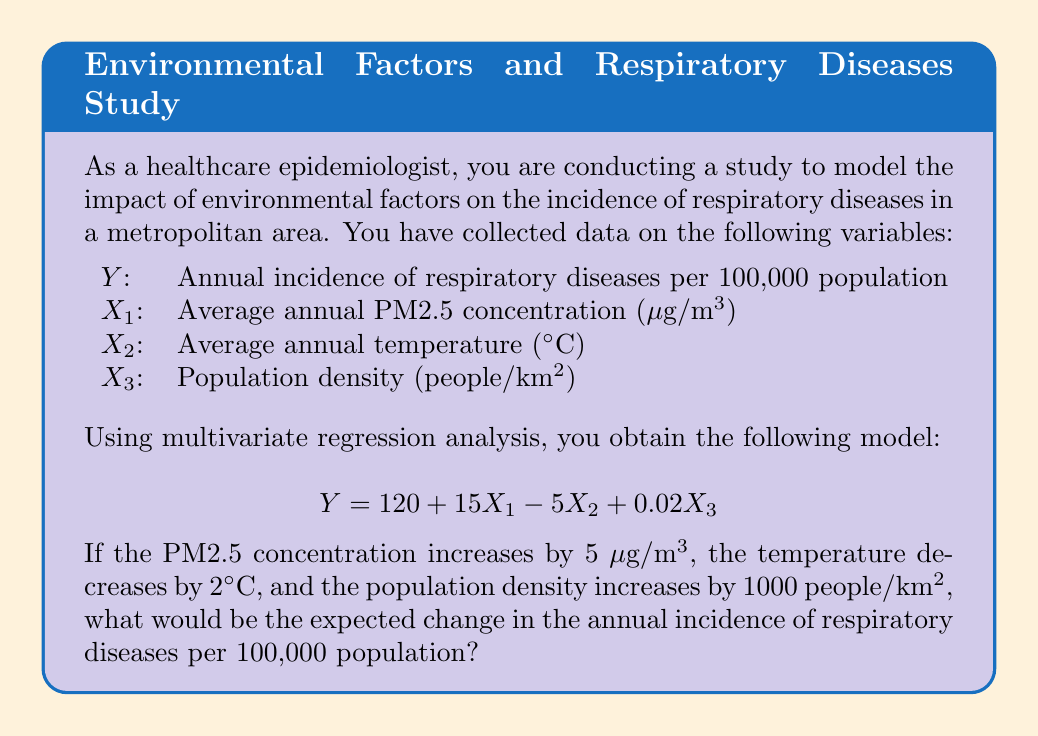Provide a solution to this math problem. To solve this problem, we need to use the given multivariate regression model and calculate the impact of changes in each independent variable on the dependent variable. Let's break it down step by step:

1. The given model is:
   $$Y = 120 + 15X_1 - 5X_2 + 0.02X_3$$

2. We need to calculate the change in Y (ΔY) based on the changes in X₁, X₂, and X₃:
   - ΔX₁ = 5 μg/m³ (increase)
   - ΔX₂ = -2°C (decrease)
   - ΔX₃ = 1000 people/km² (increase)

3. For each variable, we multiply its coefficient in the model by its change:
   - Effect of PM2.5 change: 15 * ΔX₁ = 15 * 5 = 75
   - Effect of temperature change: -5 * ΔX₂ = -5 * (-2) = 10
   - Effect of population density change: 0.02 * ΔX₃ = 0.02 * 1000 = 20

4. The total change in Y is the sum of these effects:
   ΔY = 75 + 10 + 20 = 105

Therefore, the expected change in the annual incidence of respiratory diseases per 100,000 population is an increase of 105 cases.
Answer: 105 cases per 100,000 population 